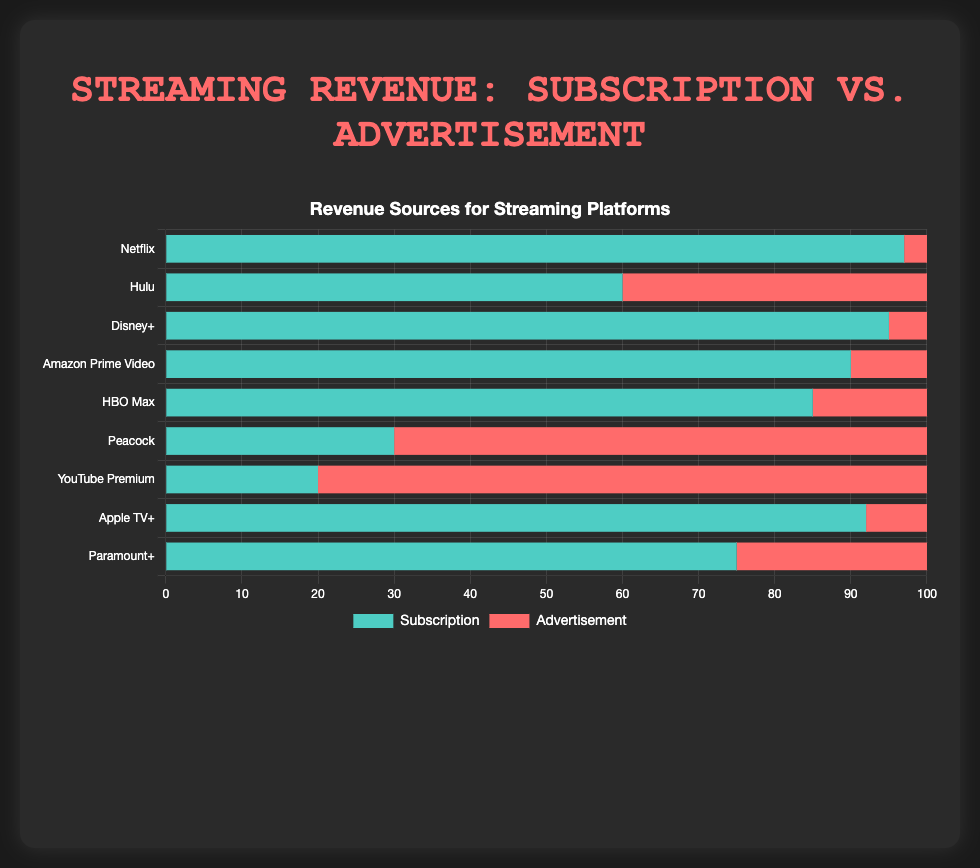Which platform has the highest percentage of revenue from subscriptions? According to the chart, Netflix has the highest percentage at 97%.
Answer: Netflix Which platform relies the least on advertisements for revenue? The chart shows that Netflix has the smallest advertisement revenue percentage at 3%.
Answer: Netflix What's the difference in the revenue percentage from advertisements between Hulu and Peacock? Hulu has 40% and Peacock has 70% revenue from advertisements. The difference is 70% - 40% = 30%.
Answer: 30% Which platform has a nearly balanced revenue from subscription and advertisement? The chart shows Hulu with 60% from subscriptions and 40% from advertisements, making it the closest to balanced.
Answer: Hulu How much more does YouTube Premium rely on advertisements compared to Apple TV+? YouTube Premium has 80% advertisement revenue, and Apple TV+ has 8%. The difference is 80% - 8% = 72%.
Answer: 72% Which two platforms have the closest percentage of revenue from subscriptions? Disney+ (95%) and Netflix (97%) have the closest subscription revenue percentages.
Answer: Disney+ and Netflix If you sum the subscription percentages of Amazon Prime Video, HBO Max, and Paramount+, what is the total? Amazon Prime Video (90%) + HBO Max (85%) + Paramount+ (75%). The sum is 90 + 85 + 75 = 250%.
Answer: 250% Which platform has the highest reliance on advertisements, and what is the percentage? The chart shows that YouTube Premium has the highest percentage of revenue from advertisements at 80%.
Answer: YouTube Premium Compare the revenue sources for Disney+ and Amazon Prime Video. Which has a higher percentage of advertisement revenue? Disney+ has 5% revenue from advertisements, while Amazon Prime Video has 10%. Amazon Prime Video has a higher percentage.
Answer: Amazon Prime Video Which platform has a greater combined total percentage from advertisement and subscription: Apple TV+ or Paramount+? Both have a combined total of 100% each, as the sum of subscription and advertisement percentages must always be 100%.
Answer: Both 